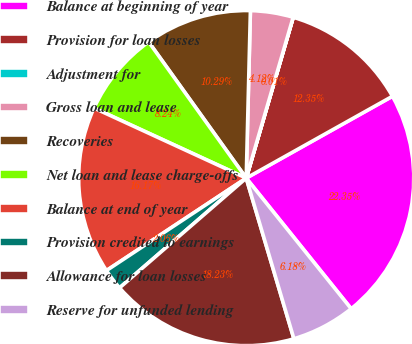<chart> <loc_0><loc_0><loc_500><loc_500><pie_chart><fcel>Balance at beginning of year<fcel>Provision for loan losses<fcel>Adjustment for<fcel>Gross loan and lease<fcel>Recoveries<fcel>Net loan and lease charge-offs<fcel>Balance at end of year<fcel>Provision credited to earnings<fcel>Allowance for loan losses<fcel>Reserve for unfunded lending<nl><fcel>22.35%<fcel>12.35%<fcel>0.01%<fcel>4.12%<fcel>10.29%<fcel>8.24%<fcel>16.17%<fcel>2.06%<fcel>18.23%<fcel>6.18%<nl></chart> 